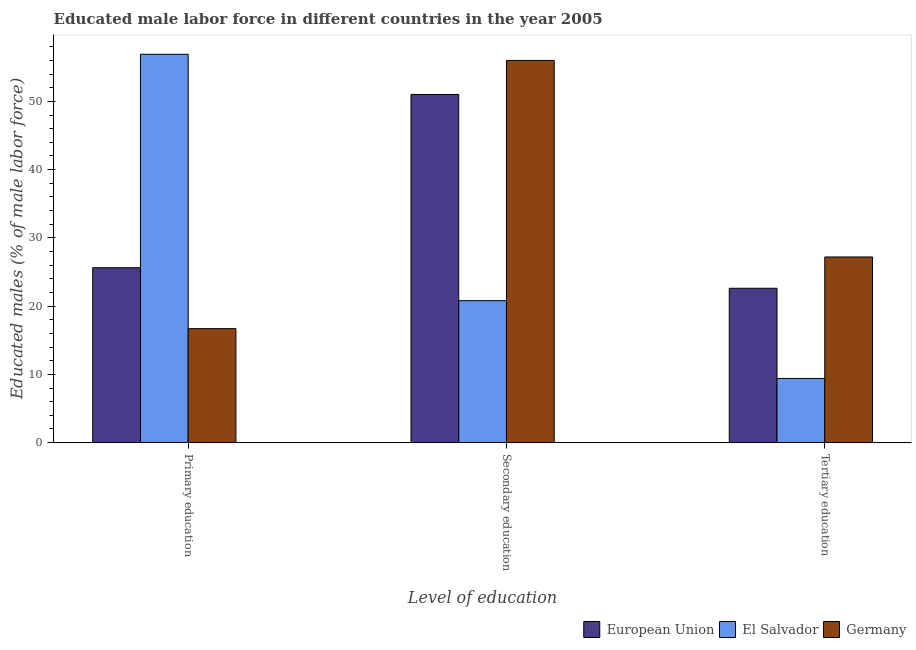How many different coloured bars are there?
Keep it short and to the point. 3. How many groups of bars are there?
Provide a short and direct response. 3. What is the label of the 1st group of bars from the left?
Give a very brief answer. Primary education. What is the percentage of male labor force who received primary education in El Salvador?
Give a very brief answer. 56.9. Across all countries, what is the maximum percentage of male labor force who received primary education?
Keep it short and to the point. 56.9. Across all countries, what is the minimum percentage of male labor force who received secondary education?
Offer a very short reply. 20.8. In which country was the percentage of male labor force who received secondary education minimum?
Your response must be concise. El Salvador. What is the total percentage of male labor force who received secondary education in the graph?
Make the answer very short. 127.81. What is the difference between the percentage of male labor force who received secondary education in El Salvador and that in European Union?
Your response must be concise. -30.21. What is the difference between the percentage of male labor force who received secondary education in European Union and the percentage of male labor force who received primary education in Germany?
Your answer should be very brief. 34.31. What is the average percentage of male labor force who received secondary education per country?
Your response must be concise. 42.6. What is the difference between the percentage of male labor force who received secondary education and percentage of male labor force who received primary education in Germany?
Ensure brevity in your answer.  39.3. In how many countries, is the percentage of male labor force who received tertiary education greater than 36 %?
Keep it short and to the point. 0. What is the ratio of the percentage of male labor force who received tertiary education in El Salvador to that in Germany?
Keep it short and to the point. 0.35. Is the percentage of male labor force who received secondary education in Germany less than that in European Union?
Offer a very short reply. No. What is the difference between the highest and the second highest percentage of male labor force who received tertiary education?
Offer a very short reply. 4.58. What is the difference between the highest and the lowest percentage of male labor force who received tertiary education?
Give a very brief answer. 17.8. Is the sum of the percentage of male labor force who received secondary education in European Union and El Salvador greater than the maximum percentage of male labor force who received primary education across all countries?
Your answer should be very brief. Yes. What does the 2nd bar from the left in Secondary education represents?
Offer a terse response. El Salvador. Are the values on the major ticks of Y-axis written in scientific E-notation?
Make the answer very short. No. Does the graph contain grids?
Your response must be concise. No. Where does the legend appear in the graph?
Your answer should be compact. Bottom right. How many legend labels are there?
Your answer should be very brief. 3. How are the legend labels stacked?
Ensure brevity in your answer.  Horizontal. What is the title of the graph?
Make the answer very short. Educated male labor force in different countries in the year 2005. What is the label or title of the X-axis?
Give a very brief answer. Level of education. What is the label or title of the Y-axis?
Keep it short and to the point. Educated males (% of male labor force). What is the Educated males (% of male labor force) in European Union in Primary education?
Provide a short and direct response. 25.62. What is the Educated males (% of male labor force) of El Salvador in Primary education?
Offer a very short reply. 56.9. What is the Educated males (% of male labor force) in Germany in Primary education?
Your answer should be compact. 16.7. What is the Educated males (% of male labor force) in European Union in Secondary education?
Make the answer very short. 51.01. What is the Educated males (% of male labor force) of El Salvador in Secondary education?
Offer a terse response. 20.8. What is the Educated males (% of male labor force) in Germany in Secondary education?
Your answer should be very brief. 56. What is the Educated males (% of male labor force) in European Union in Tertiary education?
Offer a very short reply. 22.62. What is the Educated males (% of male labor force) of El Salvador in Tertiary education?
Offer a terse response. 9.4. What is the Educated males (% of male labor force) of Germany in Tertiary education?
Your answer should be very brief. 27.2. Across all Level of education, what is the maximum Educated males (% of male labor force) of European Union?
Offer a terse response. 51.01. Across all Level of education, what is the maximum Educated males (% of male labor force) of El Salvador?
Offer a terse response. 56.9. Across all Level of education, what is the minimum Educated males (% of male labor force) of European Union?
Your answer should be very brief. 22.62. Across all Level of education, what is the minimum Educated males (% of male labor force) of El Salvador?
Keep it short and to the point. 9.4. Across all Level of education, what is the minimum Educated males (% of male labor force) of Germany?
Offer a very short reply. 16.7. What is the total Educated males (% of male labor force) in European Union in the graph?
Offer a very short reply. 99.25. What is the total Educated males (% of male labor force) of El Salvador in the graph?
Make the answer very short. 87.1. What is the total Educated males (% of male labor force) in Germany in the graph?
Give a very brief answer. 99.9. What is the difference between the Educated males (% of male labor force) of European Union in Primary education and that in Secondary education?
Keep it short and to the point. -25.39. What is the difference between the Educated males (% of male labor force) of El Salvador in Primary education and that in Secondary education?
Your answer should be very brief. 36.1. What is the difference between the Educated males (% of male labor force) of Germany in Primary education and that in Secondary education?
Provide a short and direct response. -39.3. What is the difference between the Educated males (% of male labor force) of European Union in Primary education and that in Tertiary education?
Offer a very short reply. 3.01. What is the difference between the Educated males (% of male labor force) in El Salvador in Primary education and that in Tertiary education?
Ensure brevity in your answer.  47.5. What is the difference between the Educated males (% of male labor force) in European Union in Secondary education and that in Tertiary education?
Ensure brevity in your answer.  28.4. What is the difference between the Educated males (% of male labor force) of Germany in Secondary education and that in Tertiary education?
Offer a very short reply. 28.8. What is the difference between the Educated males (% of male labor force) in European Union in Primary education and the Educated males (% of male labor force) in El Salvador in Secondary education?
Ensure brevity in your answer.  4.82. What is the difference between the Educated males (% of male labor force) of European Union in Primary education and the Educated males (% of male labor force) of Germany in Secondary education?
Provide a succinct answer. -30.38. What is the difference between the Educated males (% of male labor force) of El Salvador in Primary education and the Educated males (% of male labor force) of Germany in Secondary education?
Make the answer very short. 0.9. What is the difference between the Educated males (% of male labor force) of European Union in Primary education and the Educated males (% of male labor force) of El Salvador in Tertiary education?
Provide a short and direct response. 16.22. What is the difference between the Educated males (% of male labor force) in European Union in Primary education and the Educated males (% of male labor force) in Germany in Tertiary education?
Your answer should be compact. -1.58. What is the difference between the Educated males (% of male labor force) in El Salvador in Primary education and the Educated males (% of male labor force) in Germany in Tertiary education?
Ensure brevity in your answer.  29.7. What is the difference between the Educated males (% of male labor force) of European Union in Secondary education and the Educated males (% of male labor force) of El Salvador in Tertiary education?
Make the answer very short. 41.61. What is the difference between the Educated males (% of male labor force) in European Union in Secondary education and the Educated males (% of male labor force) in Germany in Tertiary education?
Offer a terse response. 23.81. What is the difference between the Educated males (% of male labor force) of El Salvador in Secondary education and the Educated males (% of male labor force) of Germany in Tertiary education?
Your answer should be very brief. -6.4. What is the average Educated males (% of male labor force) in European Union per Level of education?
Your response must be concise. 33.08. What is the average Educated males (% of male labor force) of El Salvador per Level of education?
Provide a succinct answer. 29.03. What is the average Educated males (% of male labor force) in Germany per Level of education?
Your response must be concise. 33.3. What is the difference between the Educated males (% of male labor force) of European Union and Educated males (% of male labor force) of El Salvador in Primary education?
Your answer should be very brief. -31.28. What is the difference between the Educated males (% of male labor force) of European Union and Educated males (% of male labor force) of Germany in Primary education?
Give a very brief answer. 8.92. What is the difference between the Educated males (% of male labor force) in El Salvador and Educated males (% of male labor force) in Germany in Primary education?
Offer a terse response. 40.2. What is the difference between the Educated males (% of male labor force) in European Union and Educated males (% of male labor force) in El Salvador in Secondary education?
Your answer should be compact. 30.21. What is the difference between the Educated males (% of male labor force) of European Union and Educated males (% of male labor force) of Germany in Secondary education?
Provide a succinct answer. -4.99. What is the difference between the Educated males (% of male labor force) in El Salvador and Educated males (% of male labor force) in Germany in Secondary education?
Provide a succinct answer. -35.2. What is the difference between the Educated males (% of male labor force) in European Union and Educated males (% of male labor force) in El Salvador in Tertiary education?
Your answer should be compact. 13.22. What is the difference between the Educated males (% of male labor force) in European Union and Educated males (% of male labor force) in Germany in Tertiary education?
Your response must be concise. -4.58. What is the difference between the Educated males (% of male labor force) of El Salvador and Educated males (% of male labor force) of Germany in Tertiary education?
Ensure brevity in your answer.  -17.8. What is the ratio of the Educated males (% of male labor force) of European Union in Primary education to that in Secondary education?
Provide a succinct answer. 0.5. What is the ratio of the Educated males (% of male labor force) of El Salvador in Primary education to that in Secondary education?
Your answer should be compact. 2.74. What is the ratio of the Educated males (% of male labor force) of Germany in Primary education to that in Secondary education?
Provide a succinct answer. 0.3. What is the ratio of the Educated males (% of male labor force) of European Union in Primary education to that in Tertiary education?
Your answer should be very brief. 1.13. What is the ratio of the Educated males (% of male labor force) of El Salvador in Primary education to that in Tertiary education?
Your response must be concise. 6.05. What is the ratio of the Educated males (% of male labor force) of Germany in Primary education to that in Tertiary education?
Give a very brief answer. 0.61. What is the ratio of the Educated males (% of male labor force) in European Union in Secondary education to that in Tertiary education?
Offer a very short reply. 2.26. What is the ratio of the Educated males (% of male labor force) of El Salvador in Secondary education to that in Tertiary education?
Ensure brevity in your answer.  2.21. What is the ratio of the Educated males (% of male labor force) of Germany in Secondary education to that in Tertiary education?
Your answer should be very brief. 2.06. What is the difference between the highest and the second highest Educated males (% of male labor force) of European Union?
Your answer should be compact. 25.39. What is the difference between the highest and the second highest Educated males (% of male labor force) of El Salvador?
Provide a succinct answer. 36.1. What is the difference between the highest and the second highest Educated males (% of male labor force) of Germany?
Provide a short and direct response. 28.8. What is the difference between the highest and the lowest Educated males (% of male labor force) in European Union?
Make the answer very short. 28.4. What is the difference between the highest and the lowest Educated males (% of male labor force) in El Salvador?
Ensure brevity in your answer.  47.5. What is the difference between the highest and the lowest Educated males (% of male labor force) of Germany?
Your answer should be very brief. 39.3. 